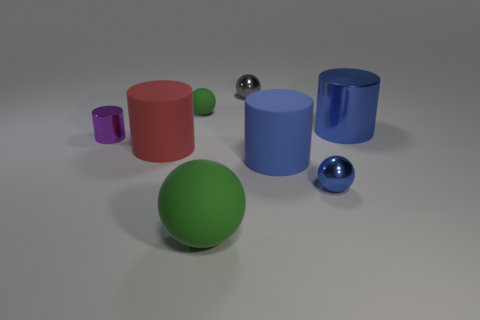What number of things are big blue cylinders or cylinders that are behind the large blue rubber object?
Give a very brief answer. 4. Do the tiny metal object that is behind the purple metal cylinder and the big rubber object right of the gray ball have the same shape?
Keep it short and to the point. No. How many objects are small purple objects or blue cylinders?
Make the answer very short. 3. Are any big cyan cylinders visible?
Provide a succinct answer. No. Do the ball that is on the right side of the gray object and the tiny purple object have the same material?
Give a very brief answer. Yes. Is there a gray object that has the same shape as the large blue metal thing?
Your response must be concise. No. Is the number of blue shiny cylinders that are left of the big metallic object the same as the number of large blue objects?
Make the answer very short. No. What is the material of the green thing in front of the big blue thing that is in front of the purple metallic cylinder?
Provide a short and direct response. Rubber. There is a red matte thing; what shape is it?
Your response must be concise. Cylinder. Are there the same number of purple cylinders in front of the red matte cylinder and tiny purple shiny cylinders on the right side of the tiny blue shiny sphere?
Your response must be concise. Yes. 